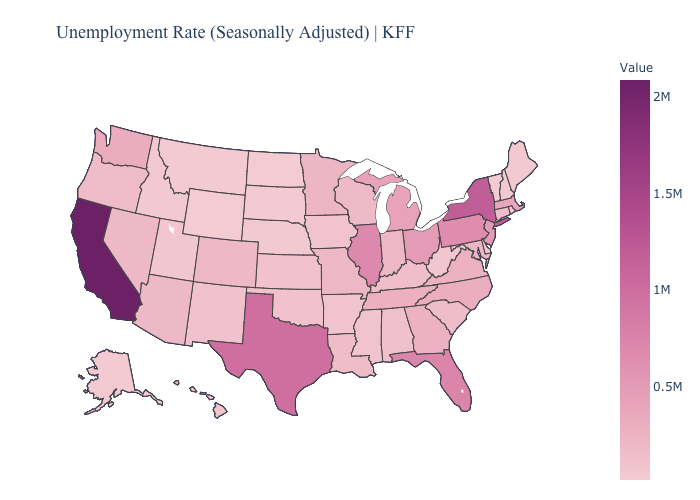Among the states that border South Carolina , does Georgia have the highest value?
Write a very short answer. No. Which states have the lowest value in the USA?
Quick response, please. Vermont. Does Pennsylvania have a higher value than Massachusetts?
Concise answer only. Yes. Is the legend a continuous bar?
Be succinct. Yes. 